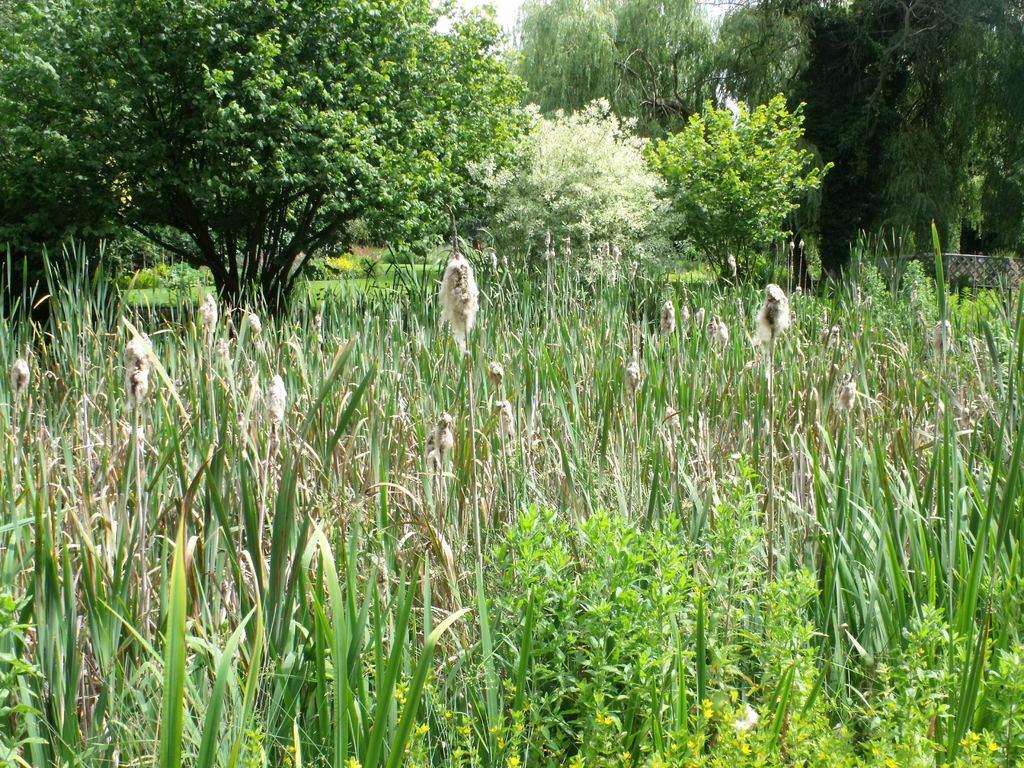In one or two sentences, can you explain what this image depicts? In this image on the ground there are plants. In the background there are trees. 